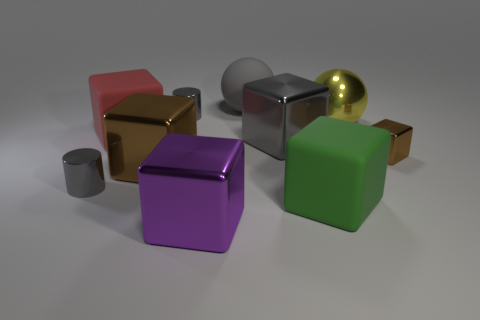Subtract 1 cubes. How many cubes are left? 5 Subtract all matte cubes. How many cubes are left? 4 Subtract all purple cubes. How many cubes are left? 5 Subtract all yellow cubes. Subtract all gray cylinders. How many cubes are left? 6 Subtract all blocks. How many objects are left? 4 Add 3 red matte blocks. How many red matte blocks exist? 4 Subtract 0 red balls. How many objects are left? 10 Subtract all tiny purple metallic things. Subtract all green blocks. How many objects are left? 9 Add 8 big purple cubes. How many big purple cubes are left? 9 